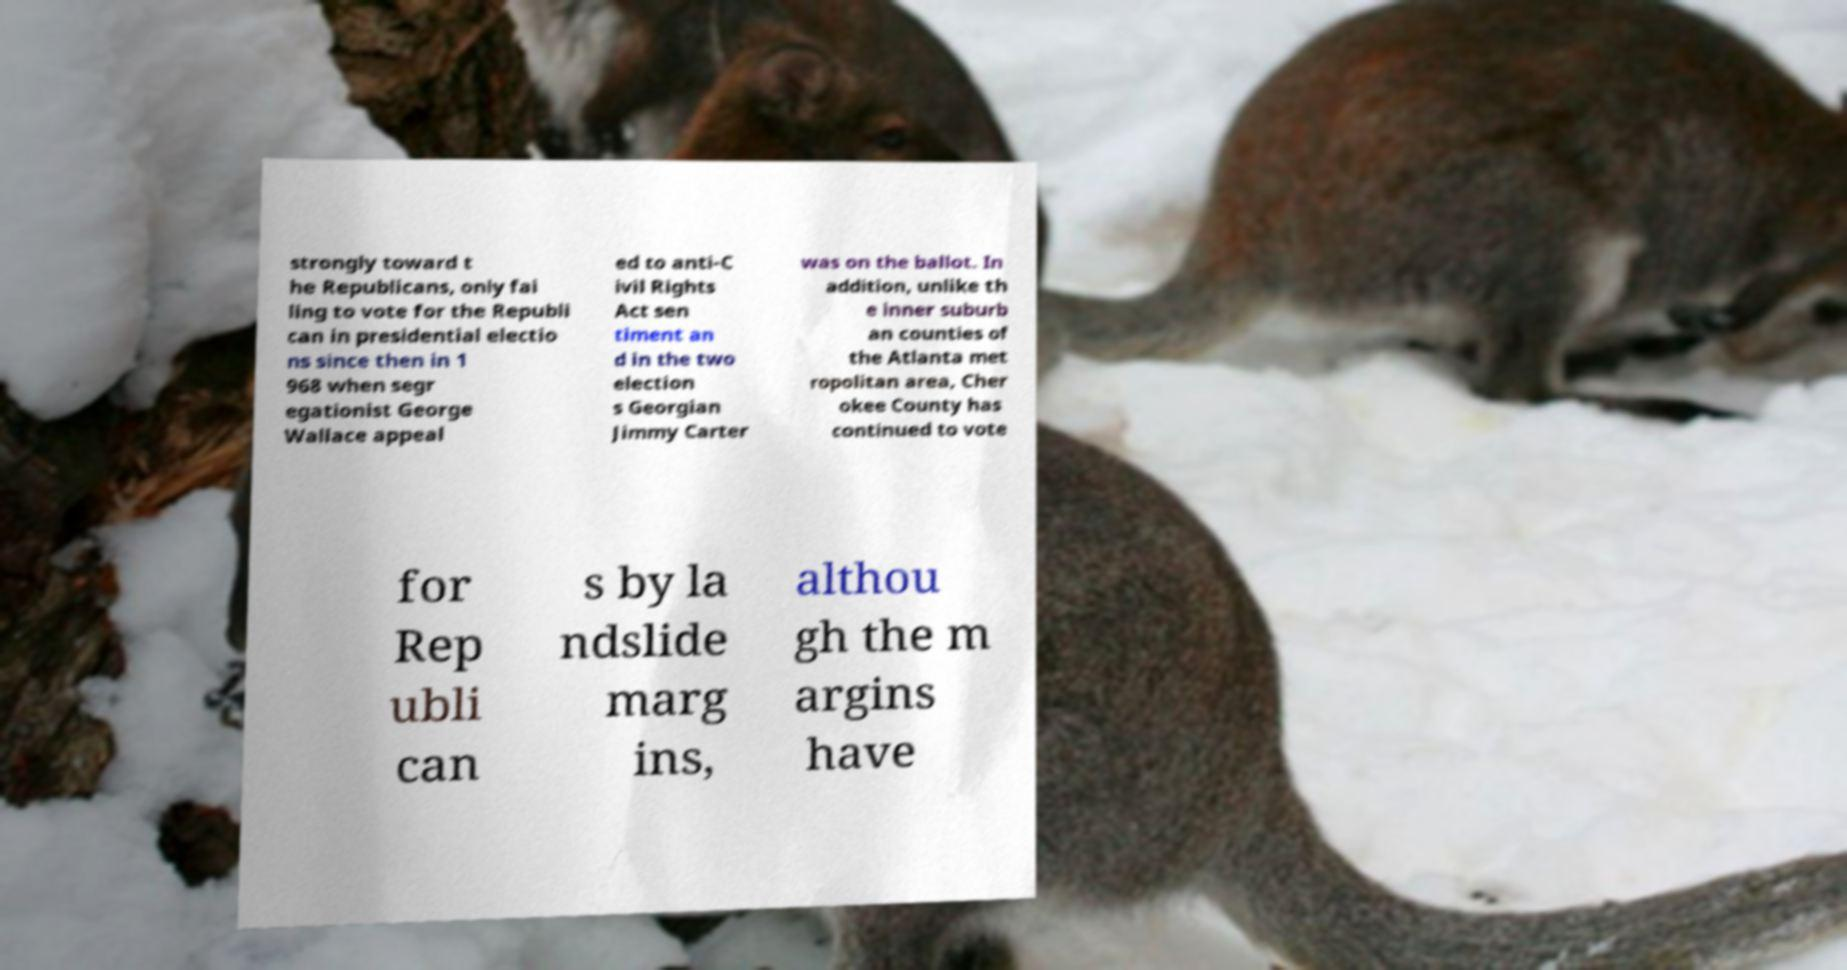Could you assist in decoding the text presented in this image and type it out clearly? strongly toward t he Republicans, only fai ling to vote for the Republi can in presidential electio ns since then in 1 968 when segr egationist George Wallace appeal ed to anti-C ivil Rights Act sen timent an d in the two election s Georgian Jimmy Carter was on the ballot. In addition, unlike th e inner suburb an counties of the Atlanta met ropolitan area, Cher okee County has continued to vote for Rep ubli can s by la ndslide marg ins, althou gh the m argins have 